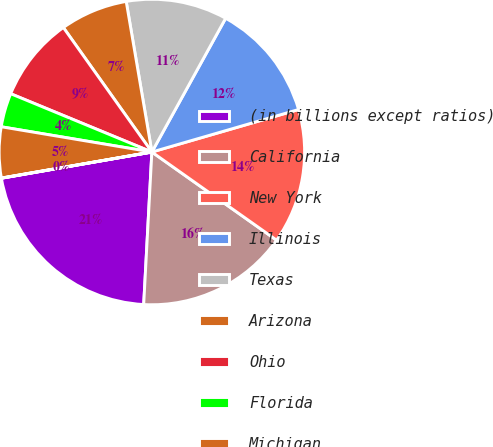<chart> <loc_0><loc_0><loc_500><loc_500><pie_chart><fcel>(in billions except ratios)<fcel>California<fcel>New York<fcel>Illinois<fcel>Texas<fcel>Arizona<fcel>Ohio<fcel>Florida<fcel>Michigan<fcel>New Jersey<nl><fcel>21.4%<fcel>16.06%<fcel>14.28%<fcel>12.49%<fcel>10.71%<fcel>7.15%<fcel>8.93%<fcel>3.59%<fcel>5.37%<fcel>0.02%<nl></chart> 